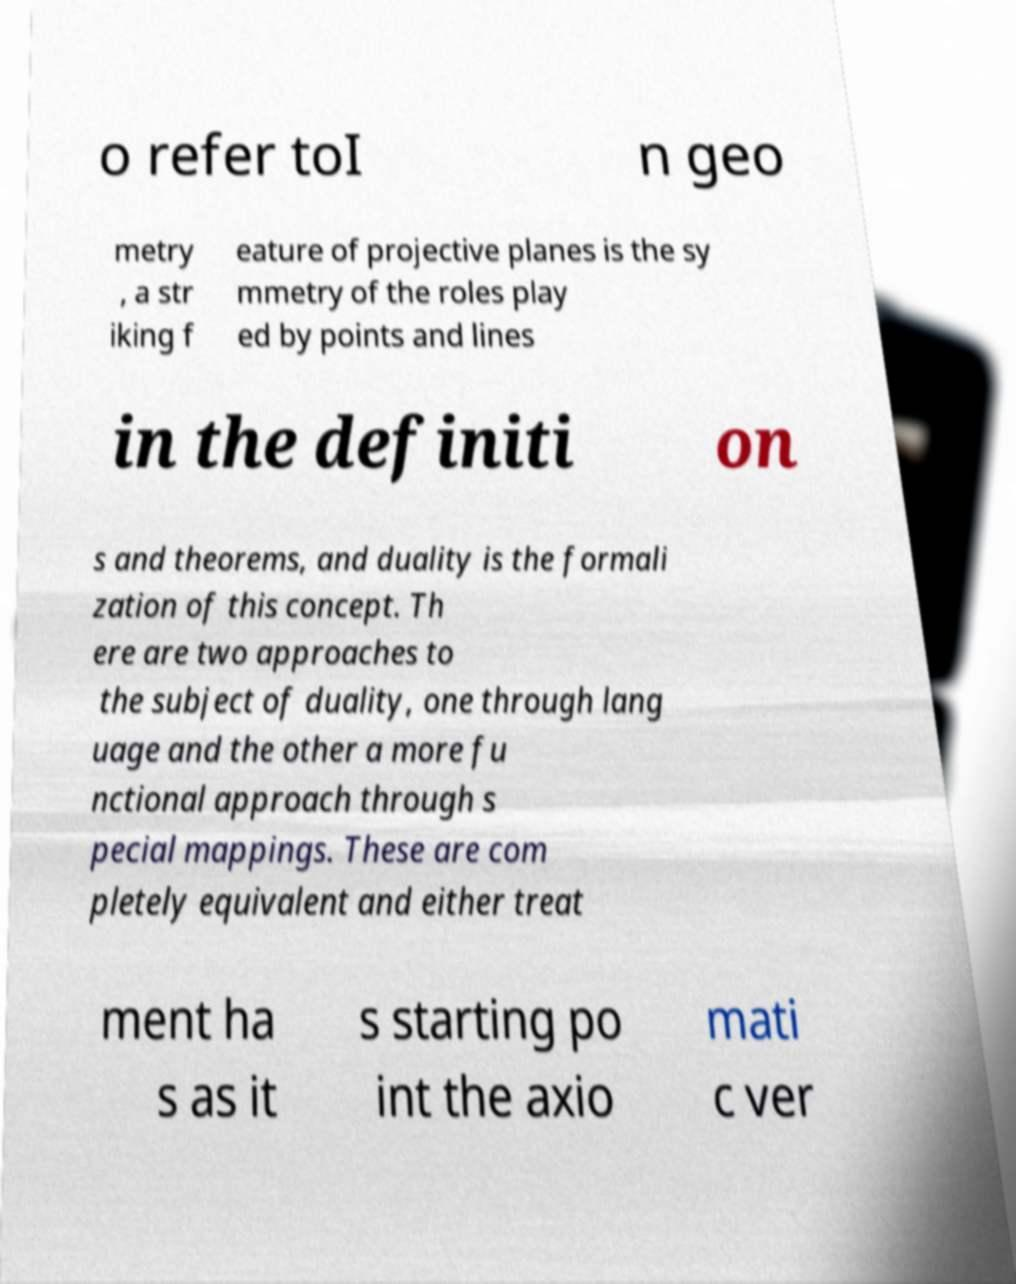For documentation purposes, I need the text within this image transcribed. Could you provide that? o refer toI n geo metry , a str iking f eature of projective planes is the sy mmetry of the roles play ed by points and lines in the definiti on s and theorems, and duality is the formali zation of this concept. Th ere are two approaches to the subject of duality, one through lang uage and the other a more fu nctional approach through s pecial mappings. These are com pletely equivalent and either treat ment ha s as it s starting po int the axio mati c ver 